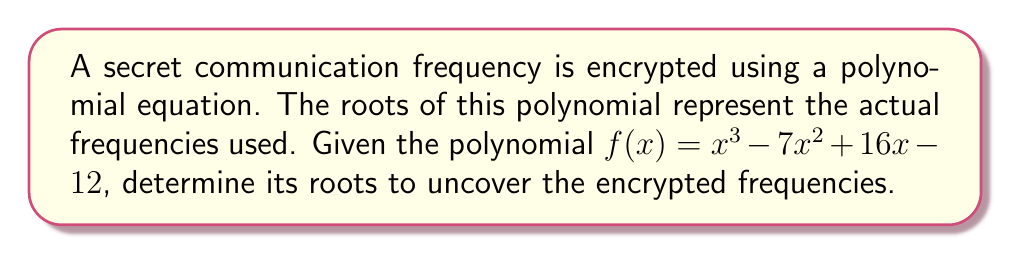Could you help me with this problem? To find the roots of the polynomial $f(x) = x^3 - 7x^2 + 16x - 12$, we need to factor it or use algebraic methods. Let's approach this step-by-step:

1) First, let's check if there are any rational roots using the rational root theorem. The possible rational roots are the factors of the constant term (12): ±1, ±2, ±3, ±4, ±6, ±12.

2) Testing these values, we find that $f(1) = 0$. So, $(x-1)$ is a factor.

3) We can now use polynomial long division to divide $f(x)$ by $(x-1)$:

   $x^3 - 7x^2 + 16x - 12 = (x-1)(x^2 - 6x + 12)$

4) Now we need to solve the quadratic equation $x^2 - 6x + 12 = 0$

5) Using the quadratic formula: $x = \frac{-b \pm \sqrt{b^2 - 4ac}}{2a}$

   Where $a=1$, $b=-6$, and $c=12$

6) Substituting:
   
   $x = \frac{6 \pm \sqrt{36 - 48}}{2} = \frac{6 \pm \sqrt{-12}}{2} = \frac{6 \pm 2i\sqrt{3}}{2} = 3 \pm i\sqrt{3}$

7) Therefore, the roots of the polynomial are:
   $x = 1$, $x = 3 + i\sqrt{3}$, and $x = 3 - i\sqrt{3}$
Answer: $1$, $3 + i\sqrt{3}$, $3 - i\sqrt{3}$ 